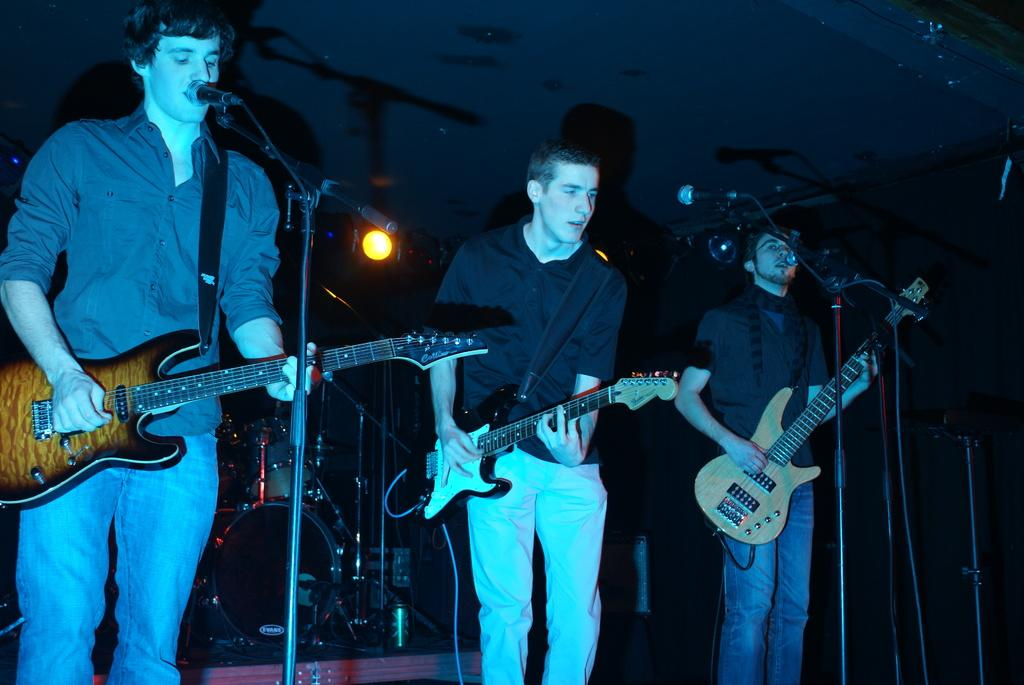How many people are in the image? There are three men in the image. What are the men doing in the image? The men are playing guitars. What equipment is set up in front of the men? There are three microphones in front of the men. Can you describe the lighting in the image? There is a light behind the men, focusing on them. What other musical instrument can be seen in the image? There is a drum set in the image. What type of bone is being used as a drumstick in the image? There is no bone being used as a drumstick in the image; the drum set is being played with traditional drumsticks. 